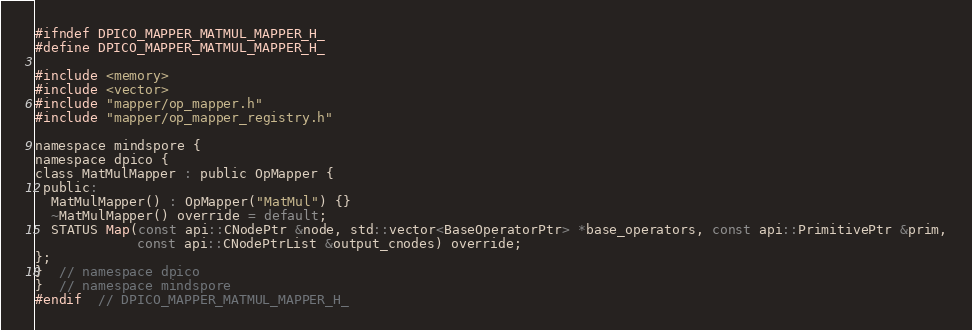<code> <loc_0><loc_0><loc_500><loc_500><_C_>#ifndef DPICO_MAPPER_MATMUL_MAPPER_H_
#define DPICO_MAPPER_MATMUL_MAPPER_H_

#include <memory>
#include <vector>
#include "mapper/op_mapper.h"
#include "mapper/op_mapper_registry.h"

namespace mindspore {
namespace dpico {
class MatMulMapper : public OpMapper {
 public:
  MatMulMapper() : OpMapper("MatMul") {}
  ~MatMulMapper() override = default;
  STATUS Map(const api::CNodePtr &node, std::vector<BaseOperatorPtr> *base_operators, const api::PrimitivePtr &prim,
             const api::CNodePtrList &output_cnodes) override;
};
}  // namespace dpico
}  // namespace mindspore
#endif  // DPICO_MAPPER_MATMUL_MAPPER_H_
</code> 